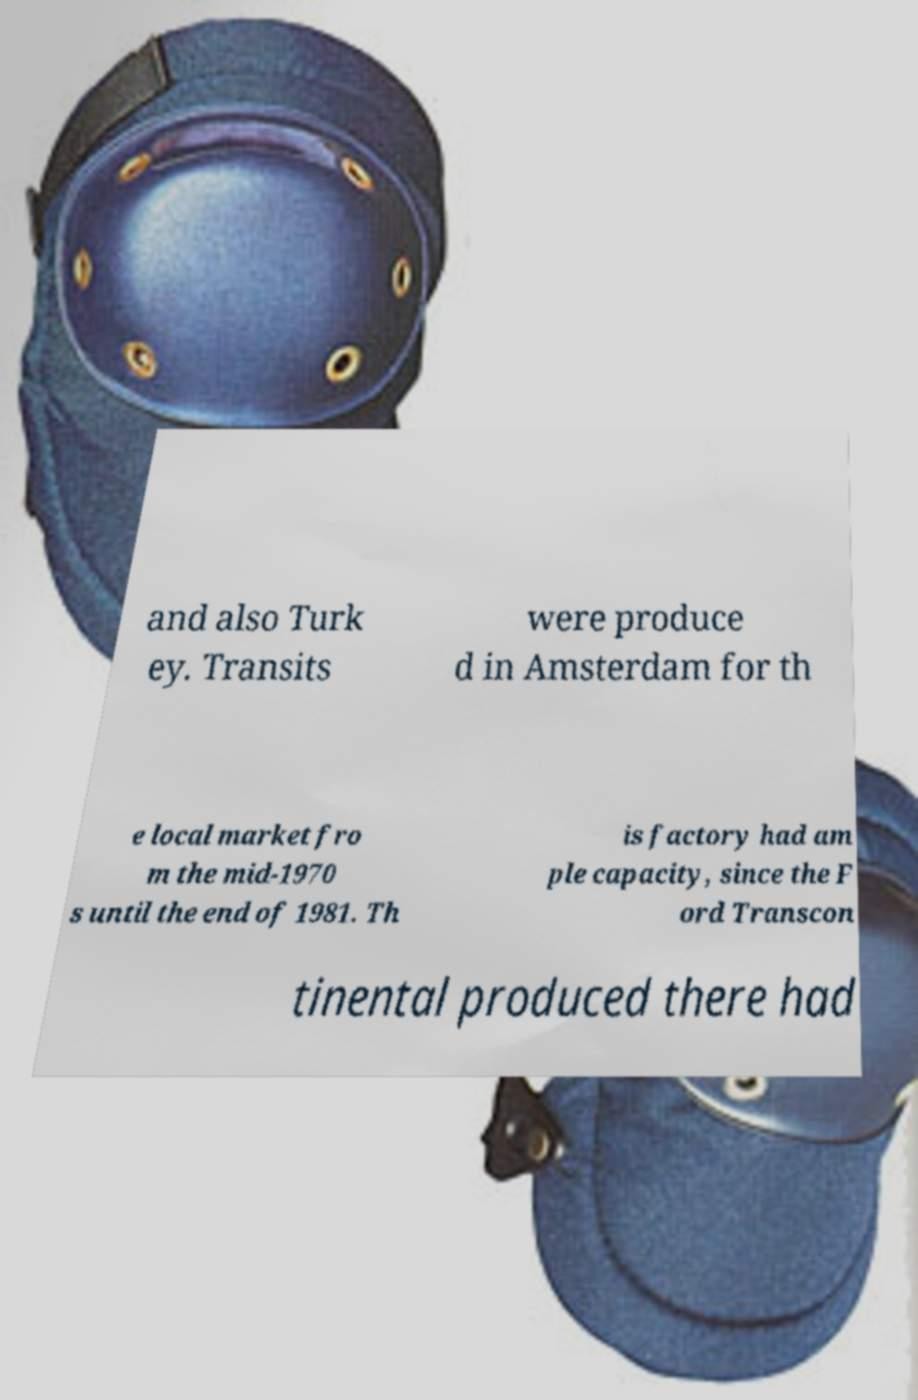I need the written content from this picture converted into text. Can you do that? and also Turk ey. Transits were produce d in Amsterdam for th e local market fro m the mid-1970 s until the end of 1981. Th is factory had am ple capacity, since the F ord Transcon tinental produced there had 